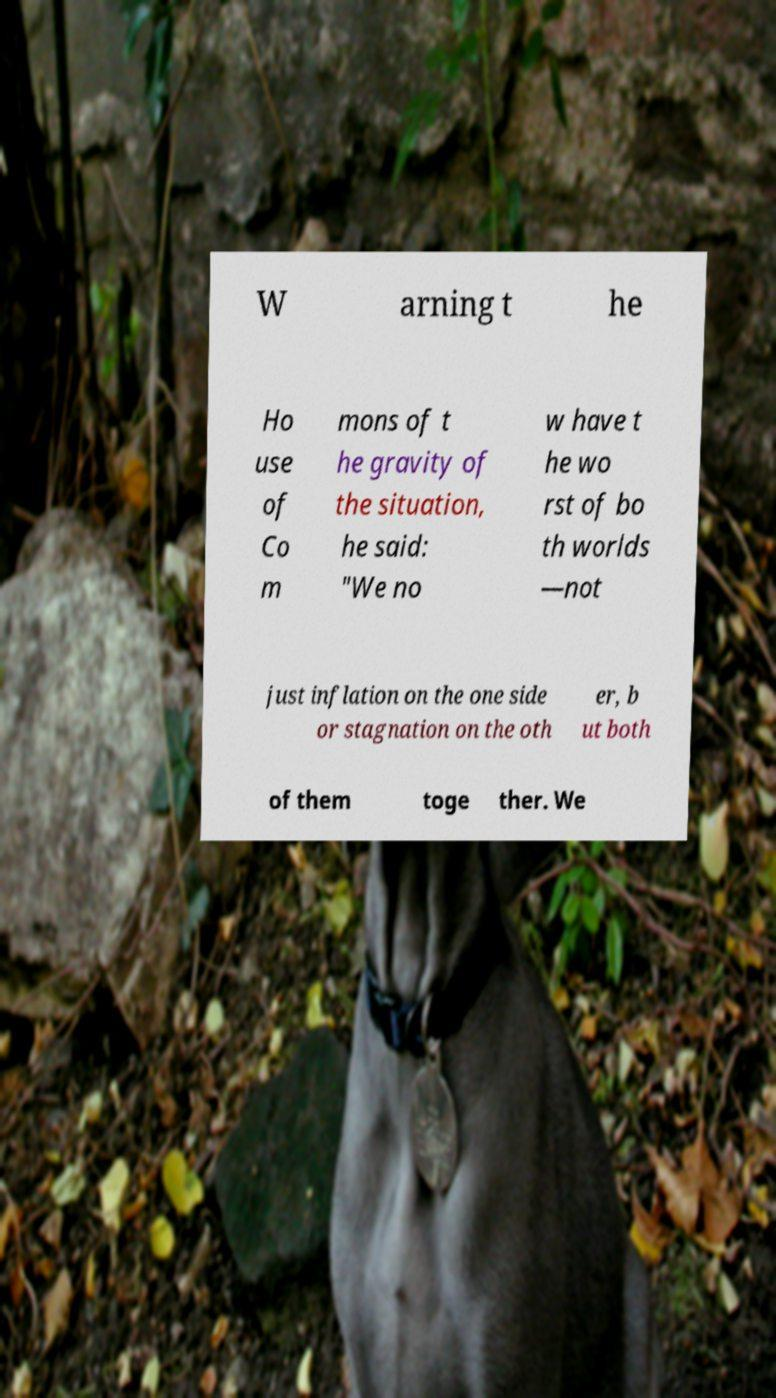Please read and relay the text visible in this image. What does it say? W arning t he Ho use of Co m mons of t he gravity of the situation, he said: "We no w have t he wo rst of bo th worlds —not just inflation on the one side or stagnation on the oth er, b ut both of them toge ther. We 